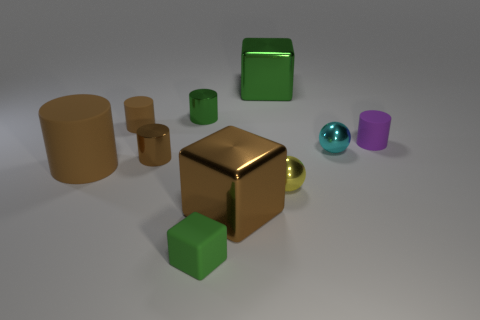How many other objects are the same size as the yellow thing?
Offer a terse response. 6. Is there a big metal cube that is behind the big metallic block on the right side of the brown thing that is on the right side of the small green rubber object?
Your answer should be very brief. No. Are there any other things that are the same color as the small block?
Offer a very short reply. Yes. What size is the brown metallic object that is behind the big brown matte object?
Offer a terse response. Small. How big is the yellow object that is behind the big shiny cube in front of the sphere behind the large brown rubber cylinder?
Offer a very short reply. Small. What color is the metallic block in front of the large green object that is on the left side of the yellow metallic sphere?
Offer a very short reply. Brown. There is another tiny thing that is the same shape as the tiny cyan thing; what is it made of?
Keep it short and to the point. Metal. Are there any other things that have the same material as the small cyan object?
Offer a very short reply. Yes. There is a large brown metal cube; are there any brown metallic things behind it?
Provide a short and direct response. Yes. How many large brown metal things are there?
Ensure brevity in your answer.  1. 